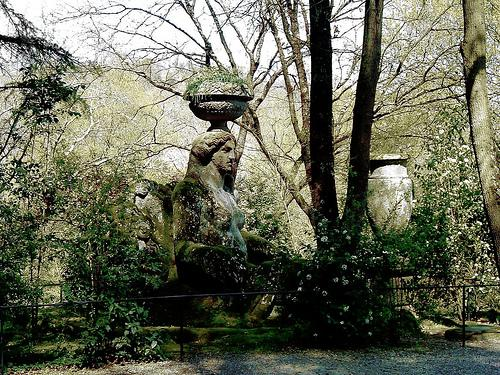Question: when was this pic taken?
Choices:
A. Morning.
B. During the day.
C. Night.
D. Winter.
Answer with the letter. Answer: B Question: how many statues do you see?
Choices:
A. 2.
B. 1.
C. 3.
D. 6.
Answer with the letter. Answer: A Question: where was this pic taken?
Choices:
A. A park.
B. At the beach.
C. Near the train tracks.
D. On a busy city street.
Answer with the letter. Answer: A Question: what stands tall all around the statues?
Choices:
A. Poles.
B. Trees.
C. Buildings.
D. Flagposts.
Answer with the letter. Answer: B Question: who is the statue of?
Choices:
A. A soldier.
B. A god.
C. A boy.
D. A man.
Answer with the letter. Answer: B 